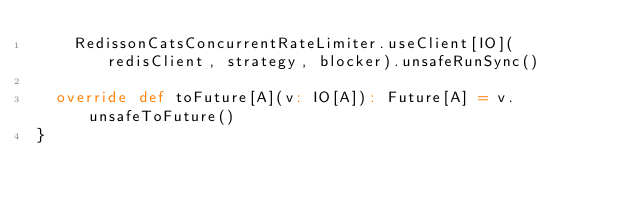Convert code to text. <code><loc_0><loc_0><loc_500><loc_500><_Scala_>    RedissonCatsConcurrentRateLimiter.useClient[IO](redisClient, strategy, blocker).unsafeRunSync()

  override def toFuture[A](v: IO[A]): Future[A] = v.unsafeToFuture()
}
</code> 